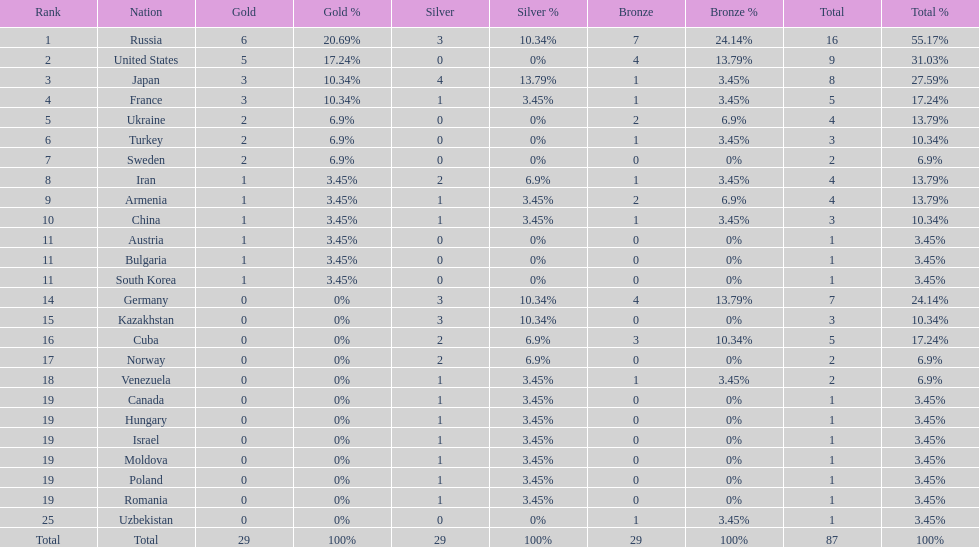Can you give me this table as a dict? {'header': ['Rank', 'Nation', 'Gold', 'Gold %', 'Silver', 'Silver %', 'Bronze', 'Bronze %', 'Total', 'Total %'], 'rows': [['1', 'Russia', '6', '20.69%', '3', '10.34%', '7', '24.14%', '16', '55.17%'], ['2', 'United States', '5', '17.24%', '0', '0%', '4', '13.79%', '9', '31.03%'], ['3', 'Japan', '3', '10.34%', '4', '13.79%', '1', '3.45%', '8', '27.59%'], ['4', 'France', '3', '10.34%', '1', '3.45%', '1', '3.45%', '5', '17.24%'], ['5', 'Ukraine', '2', '6.9%', '0', '0%', '2', '6.9%', '4', '13.79%'], ['6', 'Turkey', '2', '6.9%', '0', '0%', '1', '3.45%', '3', '10.34%'], ['7', 'Sweden', '2', '6.9%', '0', '0%', '0', '0%', '2', '6.9%'], ['8', 'Iran', '1', '3.45%', '2', '6.9%', '1', '3.45%', '4', '13.79%'], ['9', 'Armenia', '1', '3.45%', '1', '3.45%', '2', '6.9%', '4', '13.79%'], ['10', 'China', '1', '3.45%', '1', '3.45%', '1', '3.45%', '3', '10.34%'], ['11', 'Austria', '1', '3.45%', '0', '0%', '0', '0%', '1', '3.45%'], ['11', 'Bulgaria', '1', '3.45%', '0', '0%', '0', '0%', '1', '3.45%'], ['11', 'South Korea', '1', '3.45%', '0', '0%', '0', '0%', '1', '3.45%'], ['14', 'Germany', '0', '0%', '3', '10.34%', '4', '13.79%', '7', '24.14%'], ['15', 'Kazakhstan', '0', '0%', '3', '10.34%', '0', '0%', '3', '10.34%'], ['16', 'Cuba', '0', '0%', '2', '6.9%', '3', '10.34%', '5', '17.24%'], ['17', 'Norway', '0', '0%', '2', '6.9%', '0', '0%', '2', '6.9%'], ['18', 'Venezuela', '0', '0%', '1', '3.45%', '1', '3.45%', '2', '6.9%'], ['19', 'Canada', '0', '0%', '1', '3.45%', '0', '0%', '1', '3.45%'], ['19', 'Hungary', '0', '0%', '1', '3.45%', '0', '0%', '1', '3.45%'], ['19', 'Israel', '0', '0%', '1', '3.45%', '0', '0%', '1', '3.45%'], ['19', 'Moldova', '0', '0%', '1', '3.45%', '0', '0%', '1', '3.45%'], ['19', 'Poland', '0', '0%', '1', '3.45%', '0', '0%', '1', '3.45%'], ['19', 'Romania', '0', '0%', '1', '3.45%', '0', '0%', '1', '3.45%'], ['25', 'Uzbekistan', '0', '0%', '0', '0%', '1', '3.45%', '1', '3.45%'], ['Total', 'Total', '29', '100%', '29', '100%', '29', '100%', '87', '100%']]} Japan and france each won how many gold medals? 3. 